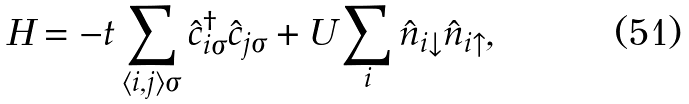Convert formula to latex. <formula><loc_0><loc_0><loc_500><loc_500>H = - t \sum _ { \langle i , j \rangle \sigma } \hat { c } ^ { \dagger } _ { i \sigma } \hat { c } _ { j \sigma } + U \sum _ { i } \hat { n } _ { i \downarrow } \hat { n } _ { i \uparrow } ,</formula> 